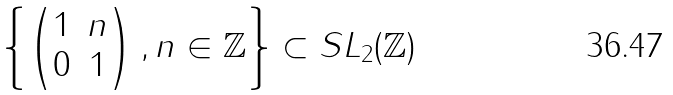Convert formula to latex. <formula><loc_0><loc_0><loc_500><loc_500>\left \{ \begin{pmatrix} 1 & n \\ 0 & 1 \end{pmatrix} , n \in \mathbb { Z } \right \} \subset S L _ { 2 } ( \mathbb { Z } )</formula> 